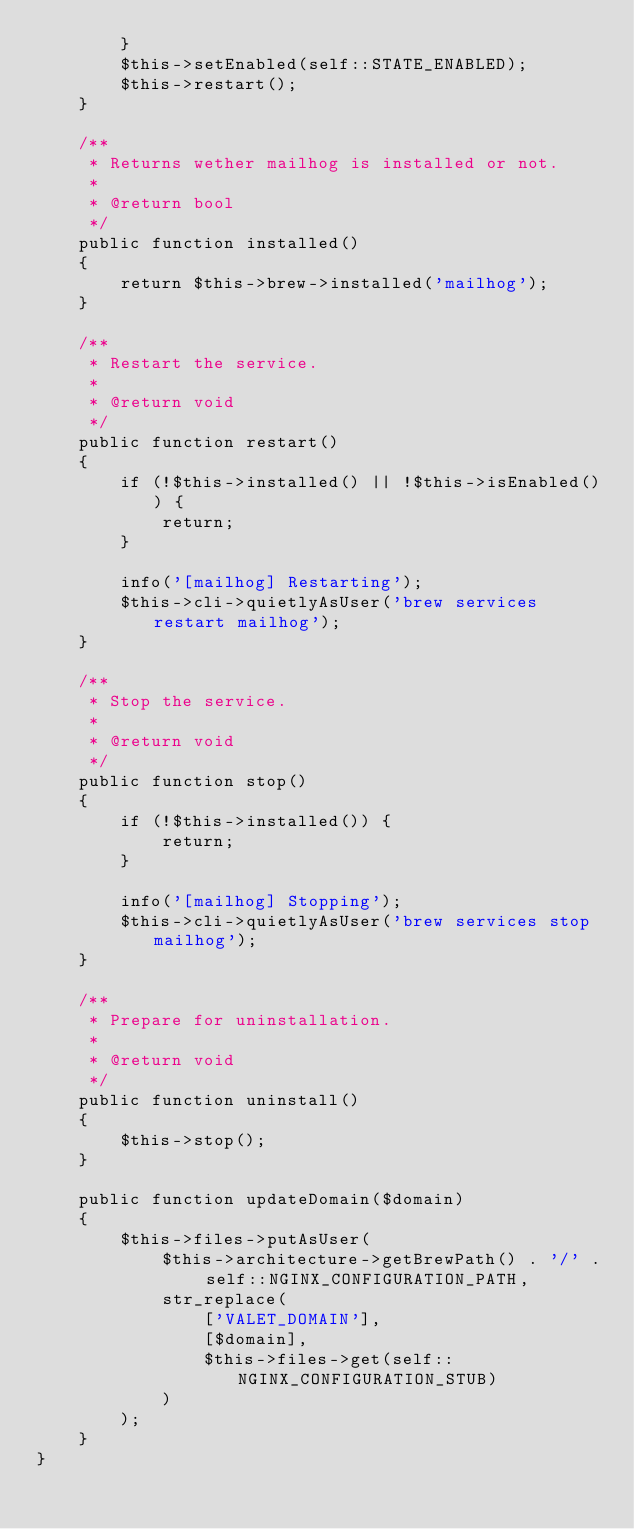Convert code to text. <code><loc_0><loc_0><loc_500><loc_500><_PHP_>        }
        $this->setEnabled(self::STATE_ENABLED);
        $this->restart();
    }

    /**
     * Returns wether mailhog is installed or not.
     *
     * @return bool
     */
    public function installed()
    {
        return $this->brew->installed('mailhog');
    }

    /**
     * Restart the service.
     *
     * @return void
     */
    public function restart()
    {
        if (!$this->installed() || !$this->isEnabled()) {
            return;
        }

        info('[mailhog] Restarting');
        $this->cli->quietlyAsUser('brew services restart mailhog');
    }

    /**
     * Stop the service.
     *
     * @return void
     */
    public function stop()
    {
        if (!$this->installed()) {
            return;
        }

        info('[mailhog] Stopping');
        $this->cli->quietlyAsUser('brew services stop mailhog');
    }

    /**
     * Prepare for uninstallation.
     *
     * @return void
     */
    public function uninstall()
    {
        $this->stop();
    }

    public function updateDomain($domain)
    {
        $this->files->putAsUser(
            $this->architecture->getBrewPath() . '/' . self::NGINX_CONFIGURATION_PATH,
            str_replace(
                ['VALET_DOMAIN'],
                [$domain],
                $this->files->get(self::NGINX_CONFIGURATION_STUB)
            )
        );
    }
}
</code> 